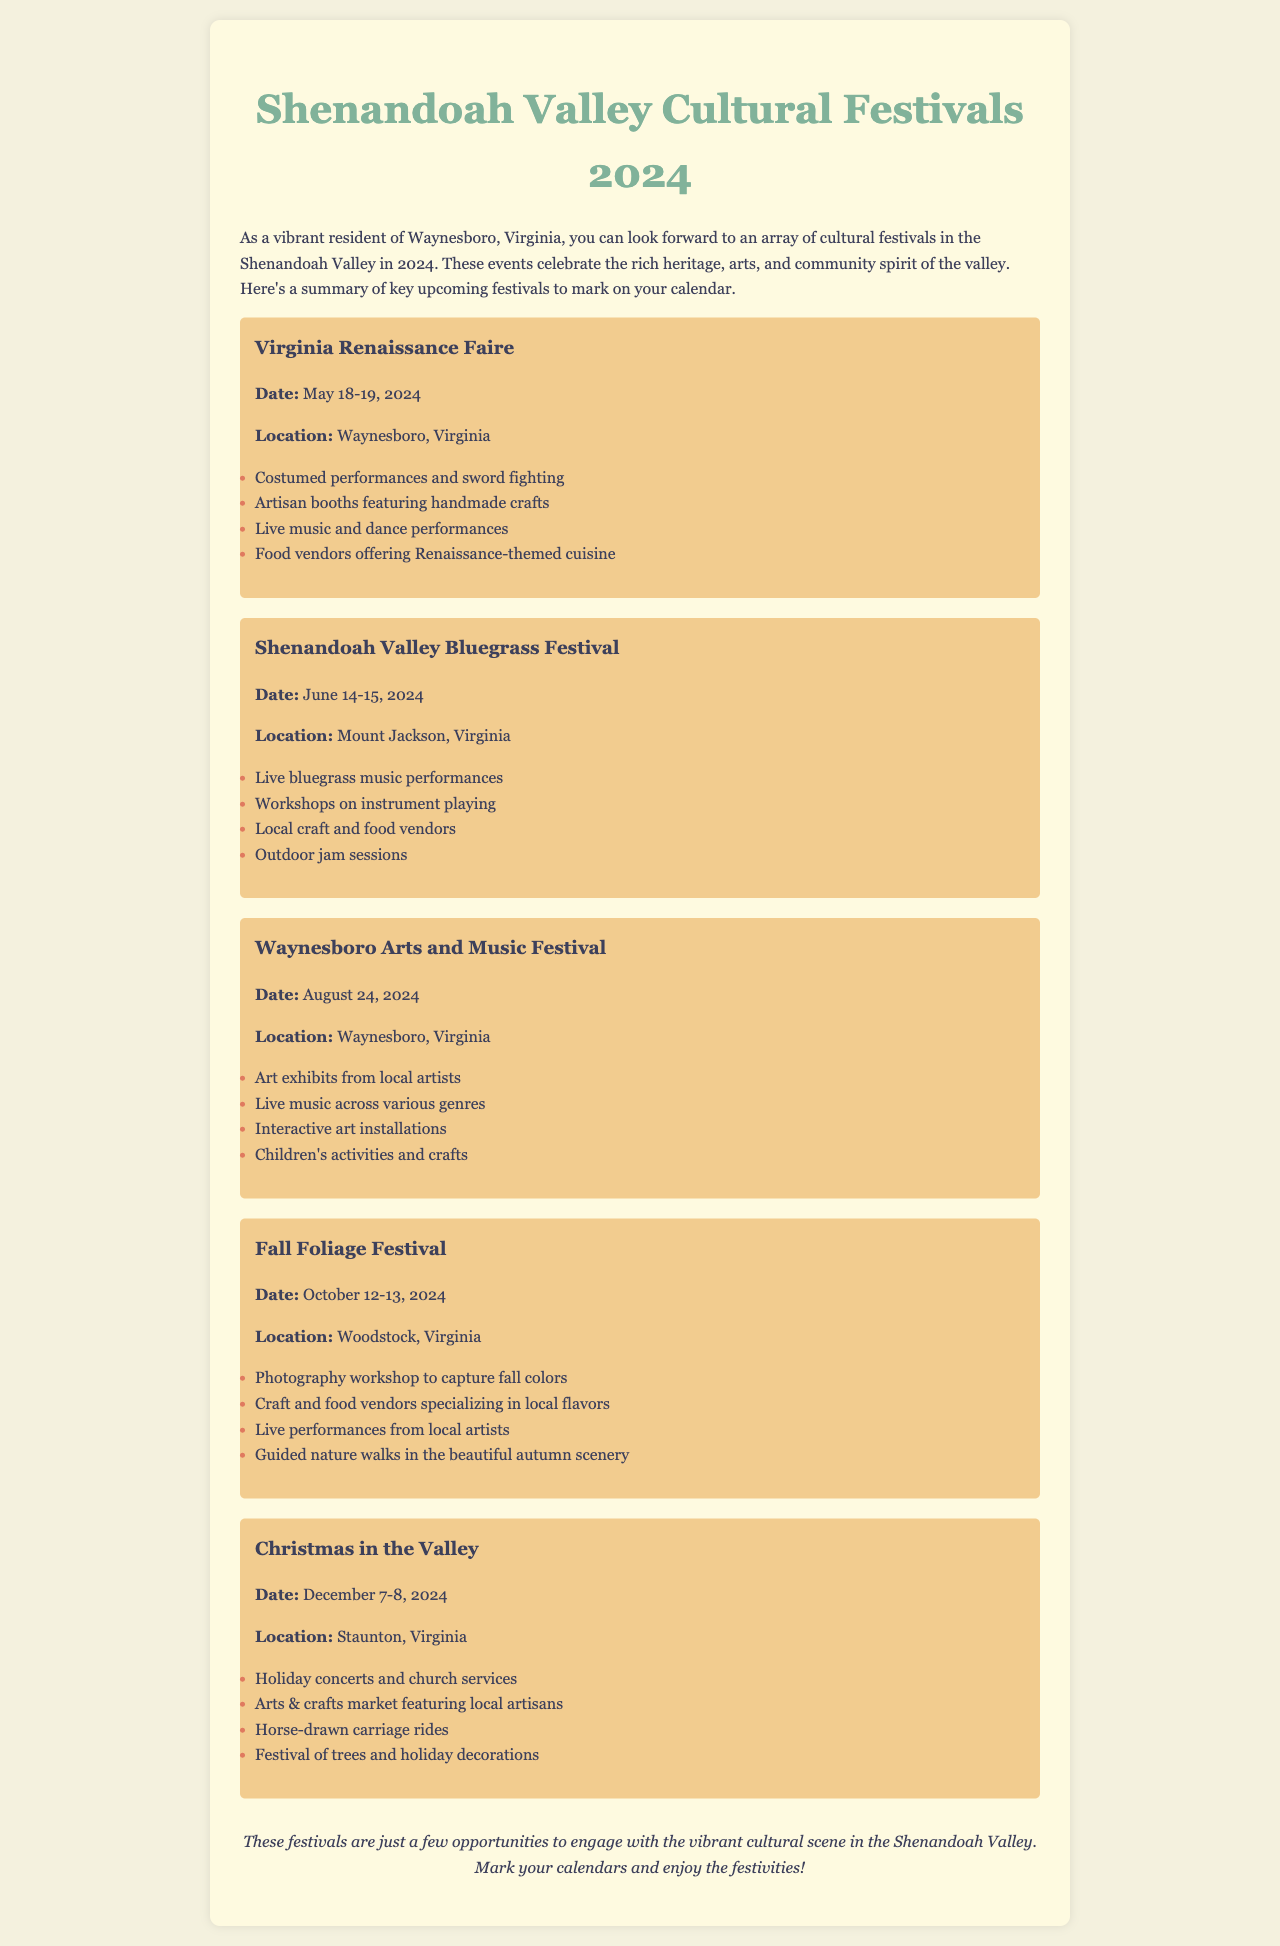What is the date of the Virginia Renaissance Faire? The date of the Virginia Renaissance Faire is mentioned in the document as May 18-19, 2024.
Answer: May 18-19, 2024 Where is the Shenandoah Valley Bluegrass Festival held? The location of the Shenandoah Valley Bluegrass Festival is stated in the document as Mount Jackson, Virginia.
Answer: Mount Jackson, Virginia What type of performances are featured at the Waynesboro Arts and Music Festival? The document details that the Waynesboro Arts and Music Festival includes live music across various genres.
Answer: Live music across various genres How many days does the Fall Foliage Festival last? The Fall Foliage Festival is scheduled for two days, October 12-13, 2024, as specified in the document.
Answer: Two days Which festival includes horse-drawn carriage rides? The document specifies that horse-drawn carriage rides are part of the Christmas in the Valley festival.
Answer: Christmas in the Valley What activities are available at the Virginia Renaissance Faire? The document lists multiple activities at the Virginia Renaissance Faire, including costumed performances and sword fighting.
Answer: Costumed performances and sword fighting Which festival is located in Staunton, Virginia? According to the document, the festival located in Staunton, Virginia is Christmas in the Valley.
Answer: Christmas in the Valley What is a feature of the Fall Foliage Festival? The Fall Foliage Festival features a photography workshop to capture fall colors, as mentioned in the document.
Answer: Photography workshop to capture fall colors 